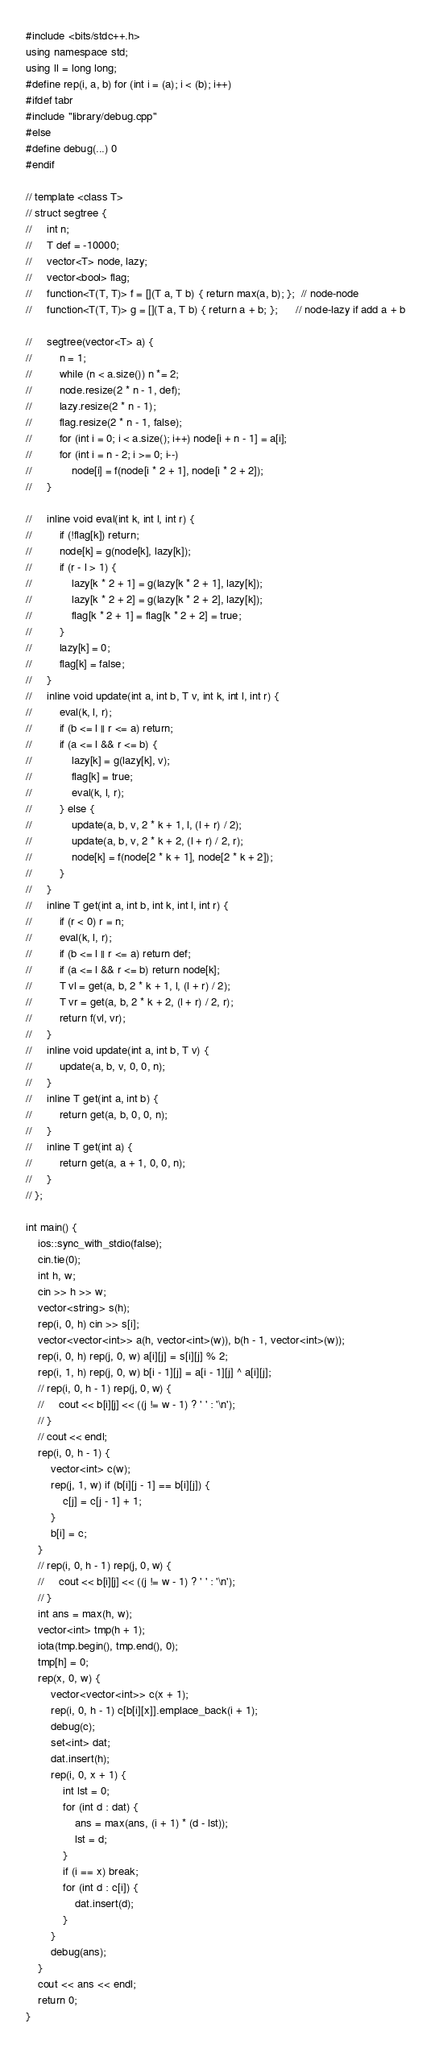<code> <loc_0><loc_0><loc_500><loc_500><_C++_>#include <bits/stdc++.h>
using namespace std;
using ll = long long;
#define rep(i, a, b) for (int i = (a); i < (b); i++)
#ifdef tabr
#include "library/debug.cpp"
#else
#define debug(...) 0
#endif

// template <class T>
// struct segtree {
//     int n;
//     T def = -10000;
//     vector<T> node, lazy;
//     vector<bool> flag;
//     function<T(T, T)> f = [](T a, T b) { return max(a, b); };  // node-node
//     function<T(T, T)> g = [](T a, T b) { return a + b; };      // node-lazy if add a + b

//     segtree(vector<T> a) {
//         n = 1;
//         while (n < a.size()) n *= 2;
//         node.resize(2 * n - 1, def);
//         lazy.resize(2 * n - 1);
//         flag.resize(2 * n - 1, false);
//         for (int i = 0; i < a.size(); i++) node[i + n - 1] = a[i];
//         for (int i = n - 2; i >= 0; i--)
//             node[i] = f(node[i * 2 + 1], node[i * 2 + 2]);
//     }

//     inline void eval(int k, int l, int r) {
//         if (!flag[k]) return;
//         node[k] = g(node[k], lazy[k]);
//         if (r - l > 1) {
//             lazy[k * 2 + 1] = g(lazy[k * 2 + 1], lazy[k]);
//             lazy[k * 2 + 2] = g(lazy[k * 2 + 2], lazy[k]);
//             flag[k * 2 + 1] = flag[k * 2 + 2] = true;
//         }
//         lazy[k] = 0;
//         flag[k] = false;
//     }
//     inline void update(int a, int b, T v, int k, int l, int r) {
//         eval(k, l, r);
//         if (b <= l || r <= a) return;
//         if (a <= l && r <= b) {
//             lazy[k] = g(lazy[k], v);
//             flag[k] = true;
//             eval(k, l, r);
//         } else {
//             update(a, b, v, 2 * k + 1, l, (l + r) / 2);
//             update(a, b, v, 2 * k + 2, (l + r) / 2, r);
//             node[k] = f(node[2 * k + 1], node[2 * k + 2]);
//         }
//     }
//     inline T get(int a, int b, int k, int l, int r) {
//         if (r < 0) r = n;
//         eval(k, l, r);
//         if (b <= l || r <= a) return def;
//         if (a <= l && r <= b) return node[k];
//         T vl = get(a, b, 2 * k + 1, l, (l + r) / 2);
//         T vr = get(a, b, 2 * k + 2, (l + r) / 2, r);
//         return f(vl, vr);
//     }
//     inline void update(int a, int b, T v) {
//         update(a, b, v, 0, 0, n);
//     }
//     inline T get(int a, int b) {
//         return get(a, b, 0, 0, n);
//     }
//     inline T get(int a) {
//         return get(a, a + 1, 0, 0, n);
//     }
// };

int main() {
    ios::sync_with_stdio(false);
    cin.tie(0);
    int h, w;
    cin >> h >> w;
    vector<string> s(h);
    rep(i, 0, h) cin >> s[i];
    vector<vector<int>> a(h, vector<int>(w)), b(h - 1, vector<int>(w));
    rep(i, 0, h) rep(j, 0, w) a[i][j] = s[i][j] % 2;
    rep(i, 1, h) rep(j, 0, w) b[i - 1][j] = a[i - 1][j] ^ a[i][j];
    // rep(i, 0, h - 1) rep(j, 0, w) {
    //     cout << b[i][j] << ((j != w - 1) ? ' ' : '\n');
    // }
    // cout << endl;
    rep(i, 0, h - 1) {
        vector<int> c(w);
        rep(j, 1, w) if (b[i][j - 1] == b[i][j]) {
            c[j] = c[j - 1] + 1;
        }
        b[i] = c;
    }
    // rep(i, 0, h - 1) rep(j, 0, w) {
    //     cout << b[i][j] << ((j != w - 1) ? ' ' : '\n');
    // }
    int ans = max(h, w);
    vector<int> tmp(h + 1);
    iota(tmp.begin(), tmp.end(), 0);
    tmp[h] = 0;
    rep(x, 0, w) {
        vector<vector<int>> c(x + 1);
        rep(i, 0, h - 1) c[b[i][x]].emplace_back(i + 1);
        debug(c);
        set<int> dat;
        dat.insert(h);
        rep(i, 0, x + 1) {
            int lst = 0;
            for (int d : dat) {
                ans = max(ans, (i + 1) * (d - lst));
                lst = d;
            }
            if (i == x) break;
            for (int d : c[i]) {
                dat.insert(d);
            }
        }
        debug(ans);
    }
    cout << ans << endl;
    return 0;
}</code> 